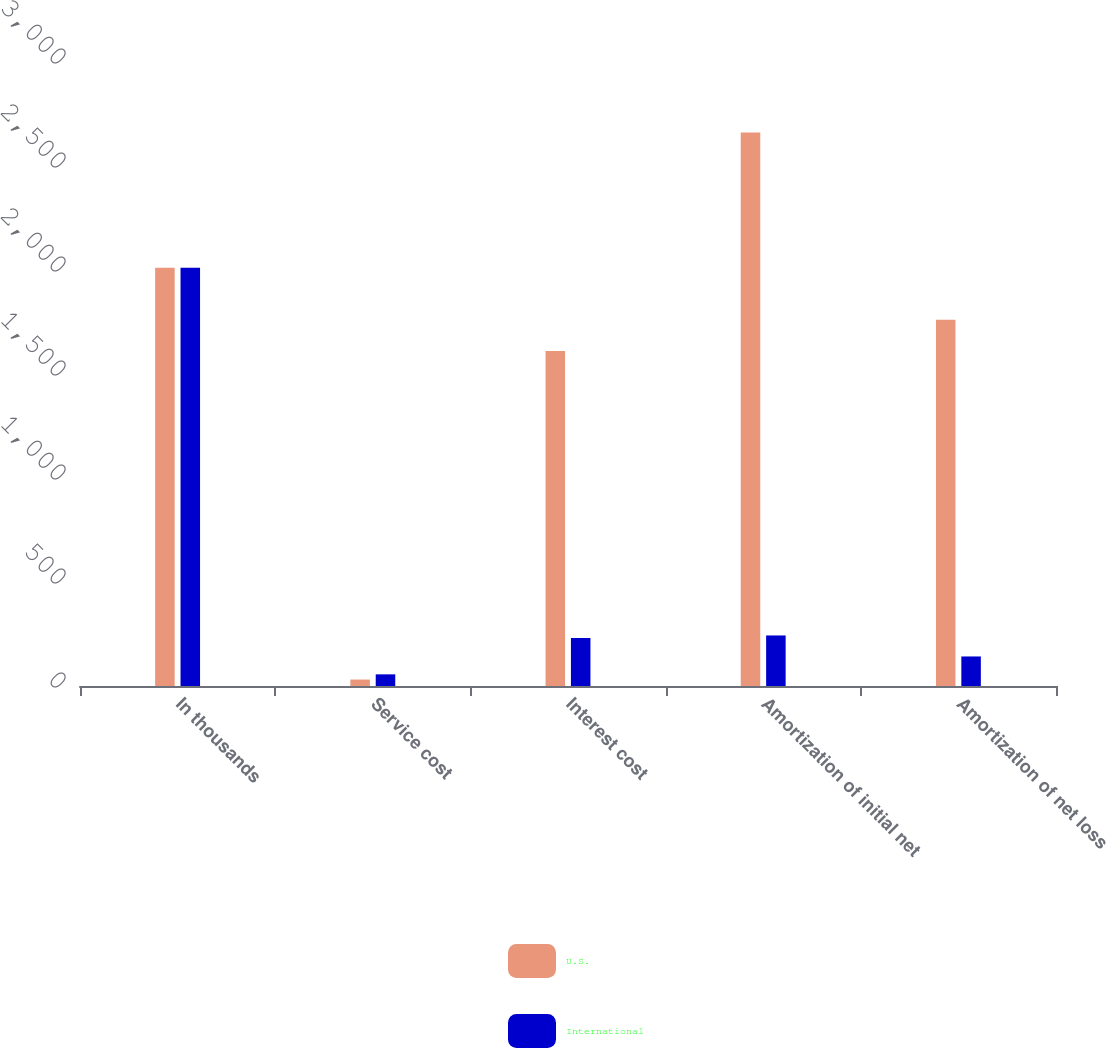Convert chart to OTSL. <chart><loc_0><loc_0><loc_500><loc_500><stacked_bar_chart><ecel><fcel>In thousands<fcel>Service cost<fcel>Interest cost<fcel>Amortization of initial net<fcel>Amortization of net loss<nl><fcel>U.S.<fcel>2011<fcel>31<fcel>1610<fcel>2661<fcel>1761<nl><fcel>International<fcel>2011<fcel>56<fcel>231<fcel>243<fcel>142<nl></chart> 